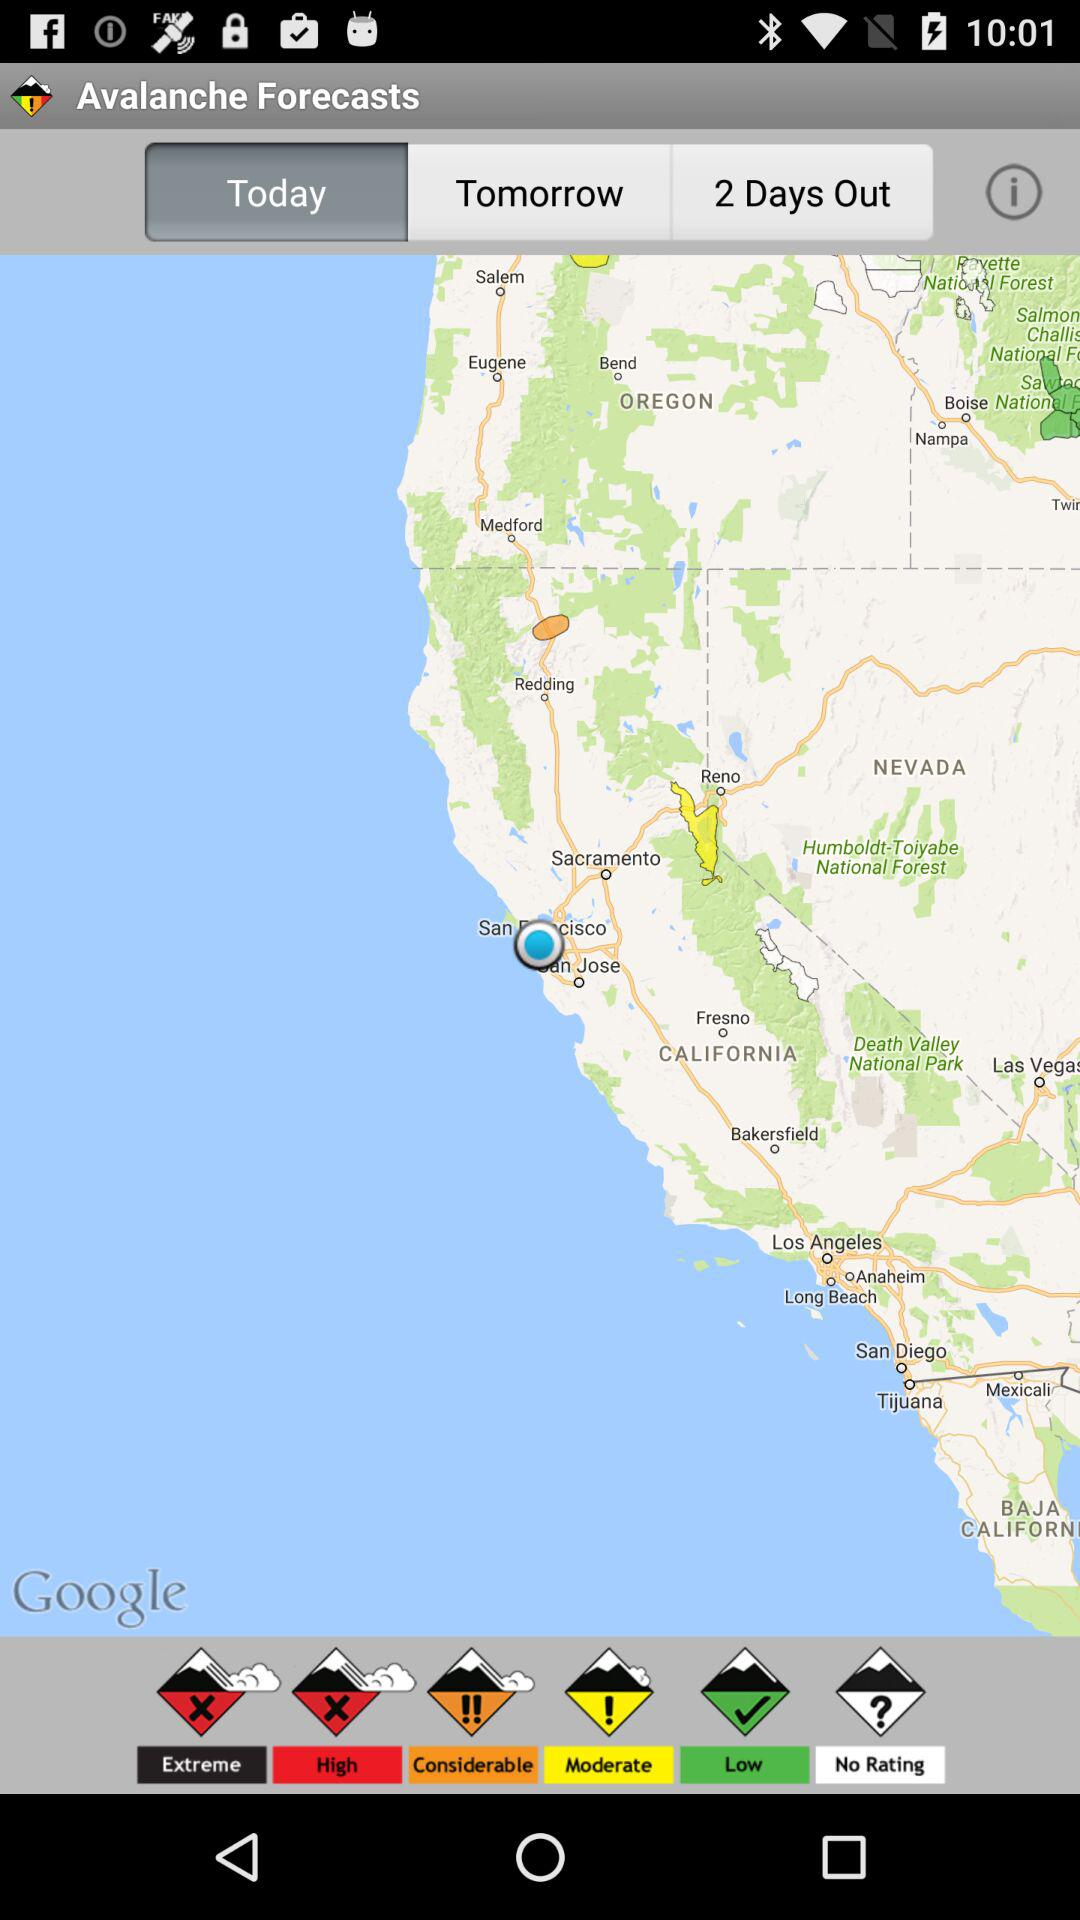Which option is selected? The selected option is "Today". 